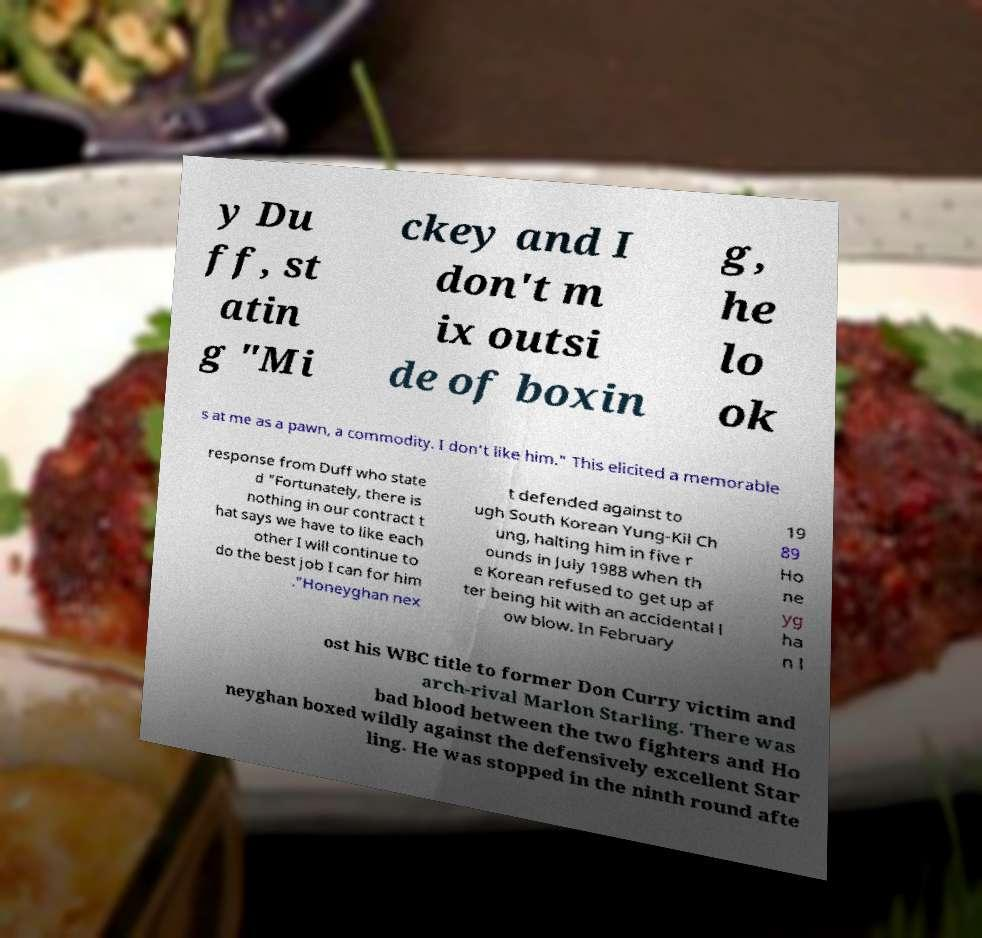There's text embedded in this image that I need extracted. Can you transcribe it verbatim? y Du ff, st atin g "Mi ckey and I don't m ix outsi de of boxin g, he lo ok s at me as a pawn, a commodity. I don't like him." This elicited a memorable response from Duff who state d "Fortunately, there is nothing in our contract t hat says we have to like each other I will continue to do the best job I can for him ."Honeyghan nex t defended against to ugh South Korean Yung-Kil Ch ung, halting him in five r ounds in July 1988 when th e Korean refused to get up af ter being hit with an accidental l ow blow. In February 19 89 Ho ne yg ha n l ost his WBC title to former Don Curry victim and arch-rival Marlon Starling. There was bad blood between the two fighters and Ho neyghan boxed wildly against the defensively excellent Star ling. He was stopped in the ninth round afte 